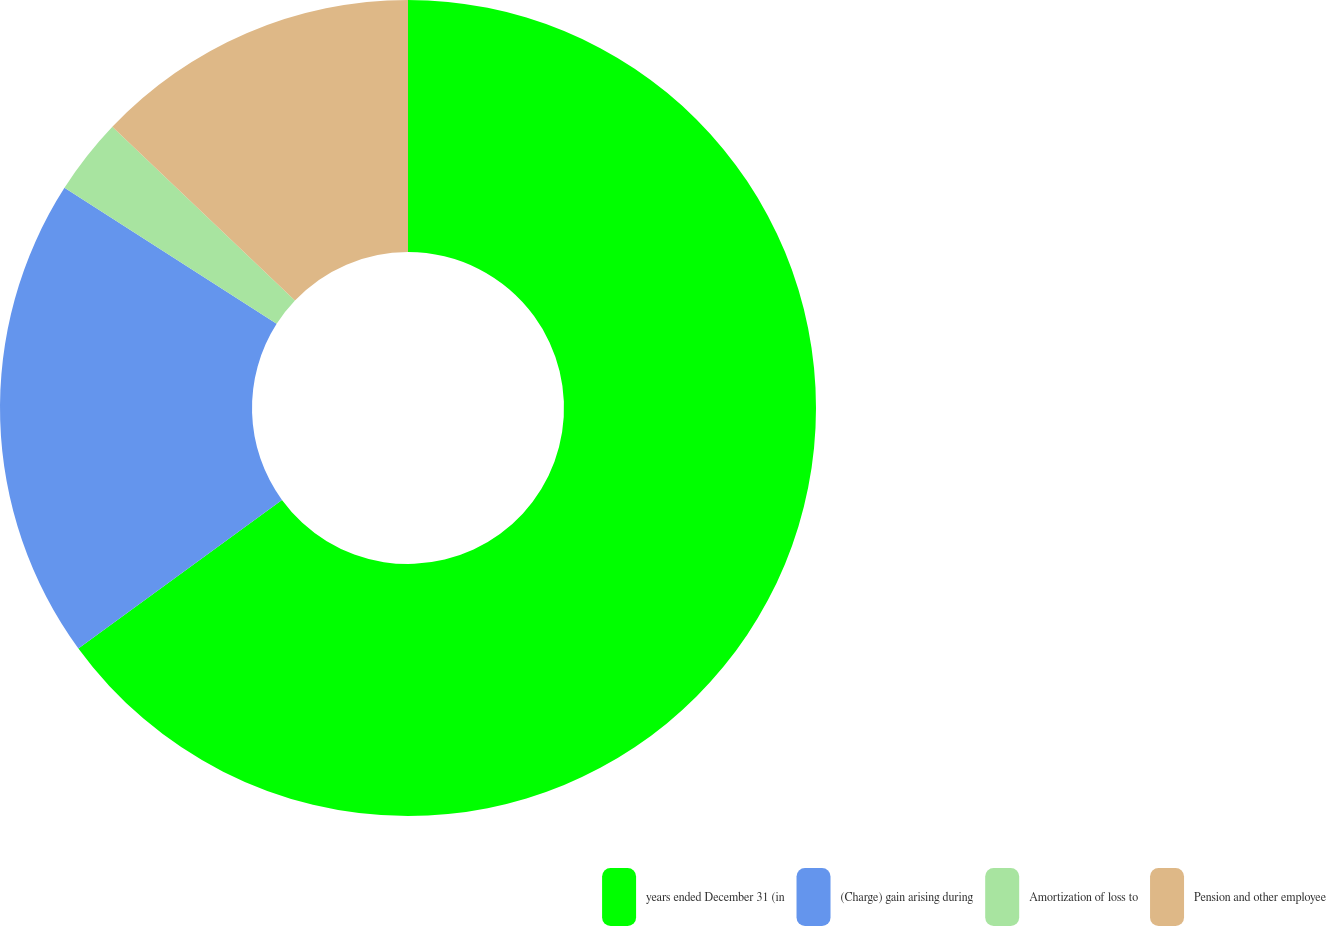<chart> <loc_0><loc_0><loc_500><loc_500><pie_chart><fcel>years ended December 31 (in<fcel>(Charge) gain arising during<fcel>Amortization of loss to<fcel>Pension and other employee<nl><fcel>64.97%<fcel>19.1%<fcel>3.03%<fcel>12.9%<nl></chart> 